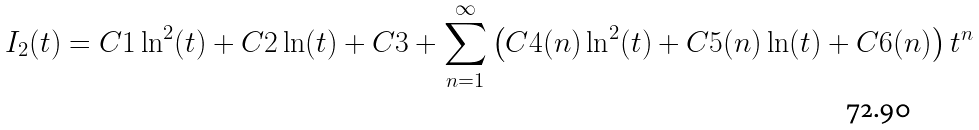<formula> <loc_0><loc_0><loc_500><loc_500>I _ { 2 } ( t ) = C 1 \ln ^ { 2 } ( t ) + C 2 \ln ( t ) + C 3 + \sum _ { n = 1 } ^ { \infty } \left ( C 4 ( n ) \ln ^ { 2 } ( t ) + C 5 ( n ) \ln ( t ) + C 6 ( n ) \right ) t ^ { n }</formula> 